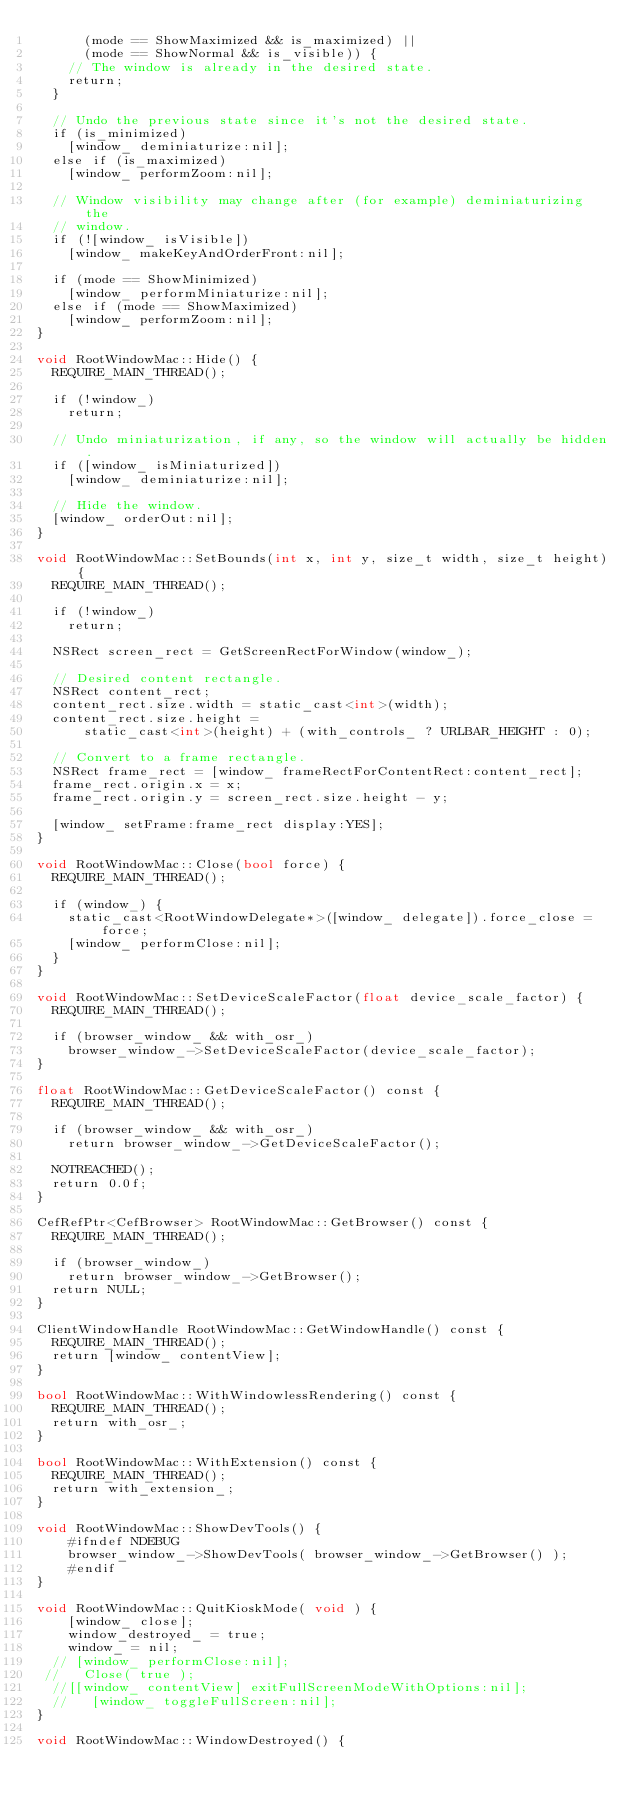Convert code to text. <code><loc_0><loc_0><loc_500><loc_500><_ObjectiveC_>      (mode == ShowMaximized && is_maximized) ||
      (mode == ShowNormal && is_visible)) {
    // The window is already in the desired state.
    return;
  }

  // Undo the previous state since it's not the desired state.
  if (is_minimized)
    [window_ deminiaturize:nil];
  else if (is_maximized)
    [window_ performZoom:nil];

  // Window visibility may change after (for example) deminiaturizing the
  // window.
  if (![window_ isVisible])
    [window_ makeKeyAndOrderFront:nil];

  if (mode == ShowMinimized)
    [window_ performMiniaturize:nil];
  else if (mode == ShowMaximized)
    [window_ performZoom:nil];
}

void RootWindowMac::Hide() {
  REQUIRE_MAIN_THREAD();

  if (!window_)
    return;

  // Undo miniaturization, if any, so the window will actually be hidden.
  if ([window_ isMiniaturized])
    [window_ deminiaturize:nil];

  // Hide the window.
  [window_ orderOut:nil];
}

void RootWindowMac::SetBounds(int x, int y, size_t width, size_t height) {
  REQUIRE_MAIN_THREAD();

  if (!window_)
    return;

  NSRect screen_rect = GetScreenRectForWindow(window_);

  // Desired content rectangle.
  NSRect content_rect;
  content_rect.size.width = static_cast<int>(width);
  content_rect.size.height =
      static_cast<int>(height) + (with_controls_ ? URLBAR_HEIGHT : 0);

  // Convert to a frame rectangle.
  NSRect frame_rect = [window_ frameRectForContentRect:content_rect];
  frame_rect.origin.x = x;
  frame_rect.origin.y = screen_rect.size.height - y;

  [window_ setFrame:frame_rect display:YES];
}

void RootWindowMac::Close(bool force) {
  REQUIRE_MAIN_THREAD();

  if (window_) {
    static_cast<RootWindowDelegate*>([window_ delegate]).force_close = force;
    [window_ performClose:nil];
  }
}

void RootWindowMac::SetDeviceScaleFactor(float device_scale_factor) {
  REQUIRE_MAIN_THREAD();

  if (browser_window_ && with_osr_)
    browser_window_->SetDeviceScaleFactor(device_scale_factor);
}

float RootWindowMac::GetDeviceScaleFactor() const {
  REQUIRE_MAIN_THREAD();

  if (browser_window_ && with_osr_)
    return browser_window_->GetDeviceScaleFactor();

  NOTREACHED();
  return 0.0f;
}

CefRefPtr<CefBrowser> RootWindowMac::GetBrowser() const {
  REQUIRE_MAIN_THREAD();

  if (browser_window_)
    return browser_window_->GetBrowser();
  return NULL;
}

ClientWindowHandle RootWindowMac::GetWindowHandle() const {
  REQUIRE_MAIN_THREAD();
  return [window_ contentView];
}

bool RootWindowMac::WithWindowlessRendering() const {
  REQUIRE_MAIN_THREAD();
  return with_osr_;
}

bool RootWindowMac::WithExtension() const {
  REQUIRE_MAIN_THREAD();
  return with_extension_;
}
    
void RootWindowMac::ShowDevTools() {
    #ifndef NDEBUG
    browser_window_->ShowDevTools( browser_window_->GetBrowser() );
    #endif
}
    
void RootWindowMac::QuitKioskMode( void ) {
    [window_ close];
    window_destroyed_ = true;
    window_ = nil;
  // [window_ performClose:nil];
 //   Close( true );
  //[[window_ contentView] exitFullScreenModeWithOptions:nil];
  //   [window_ toggleFullScreen:nil];
}

void RootWindowMac::WindowDestroyed() {</code> 